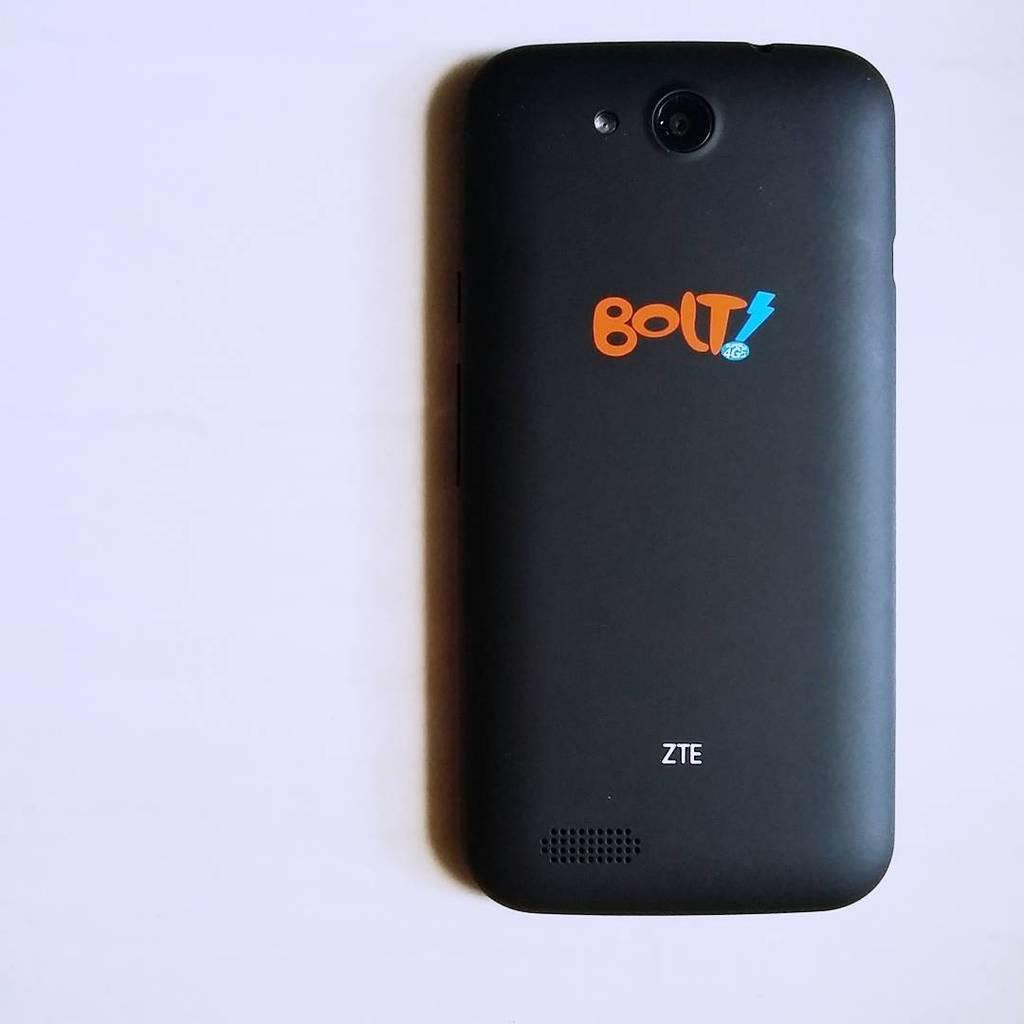<image>
Present a compact description of the photo's key features. A ZTE cell phone is face down and says BOLT! on the back in orange letters. 